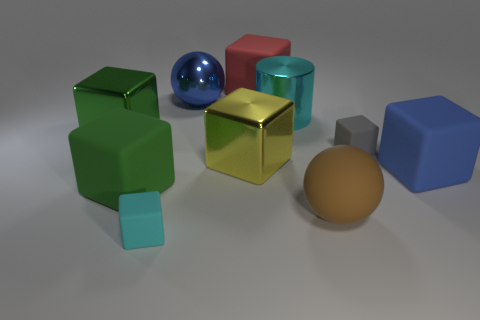What is the color of the large rubber block that is both in front of the red rubber object and on the right side of the large yellow cube?
Your response must be concise. Blue. Are there any yellow cylinders made of the same material as the tiny cyan thing?
Provide a succinct answer. No. What is the size of the cyan rubber thing?
Ensure brevity in your answer.  Small. What size is the gray matte cube behind the big rubber cube on the right side of the brown thing?
Your answer should be compact. Small. There is another big thing that is the same shape as the large blue metal object; what material is it?
Ensure brevity in your answer.  Rubber. How many spheres are there?
Ensure brevity in your answer.  2. What is the color of the large ball that is in front of the big matte cube that is on the left side of the yellow thing that is in front of the green metal object?
Provide a short and direct response. Brown. Is the number of large blue matte blocks less than the number of large yellow matte cylinders?
Keep it short and to the point. No. There is another small thing that is the same shape as the tiny gray object; what is its color?
Ensure brevity in your answer.  Cyan. What color is the sphere that is made of the same material as the tiny cyan cube?
Offer a very short reply. Brown. 